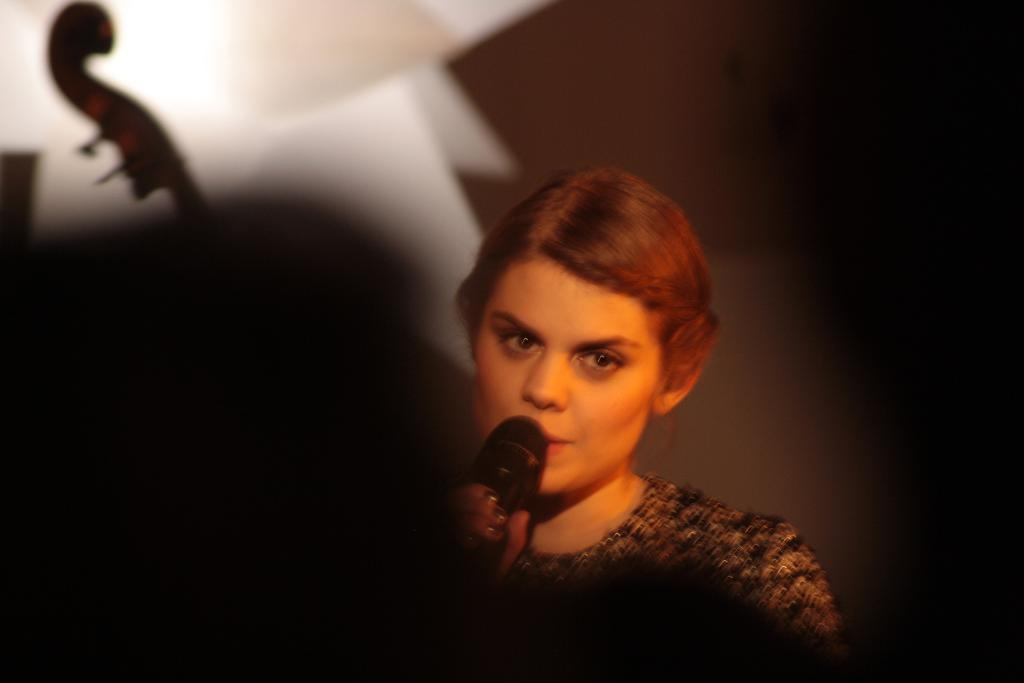Who is the main subject in the image? There is a woman in the image. What is the woman holding in her hand? The woman is holding a mic in her hand. What is the woman doing in the image? The woman is singing. Can you describe the woman's outfit in the image? The woman is wearing a brown and black dress. What type of produce can be seen in the image? There is no produce present in the image. How many eggs are visible in the image? There are no eggs visible in the image. 